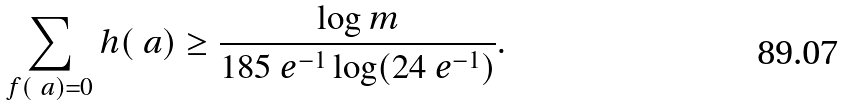<formula> <loc_0><loc_0><loc_500><loc_500>\sum _ { f ( \ a ) = 0 } h ( \ a ) \geq \frac { \log m } { 1 8 5 \ e ^ { - 1 } \log ( 2 4 \ e ^ { - 1 } ) } .</formula> 